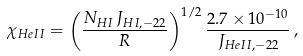Convert formula to latex. <formula><loc_0><loc_0><loc_500><loc_500>\chi _ { H e I I } = \left ( \frac { N _ { H I } \, J _ { H I , - 2 2 } } { R } \right ) ^ { 1 / 2 } \frac { 2 . 7 \times 1 0 ^ { - 1 0 } } { J _ { H e I I , - 2 2 } } \, ,</formula> 